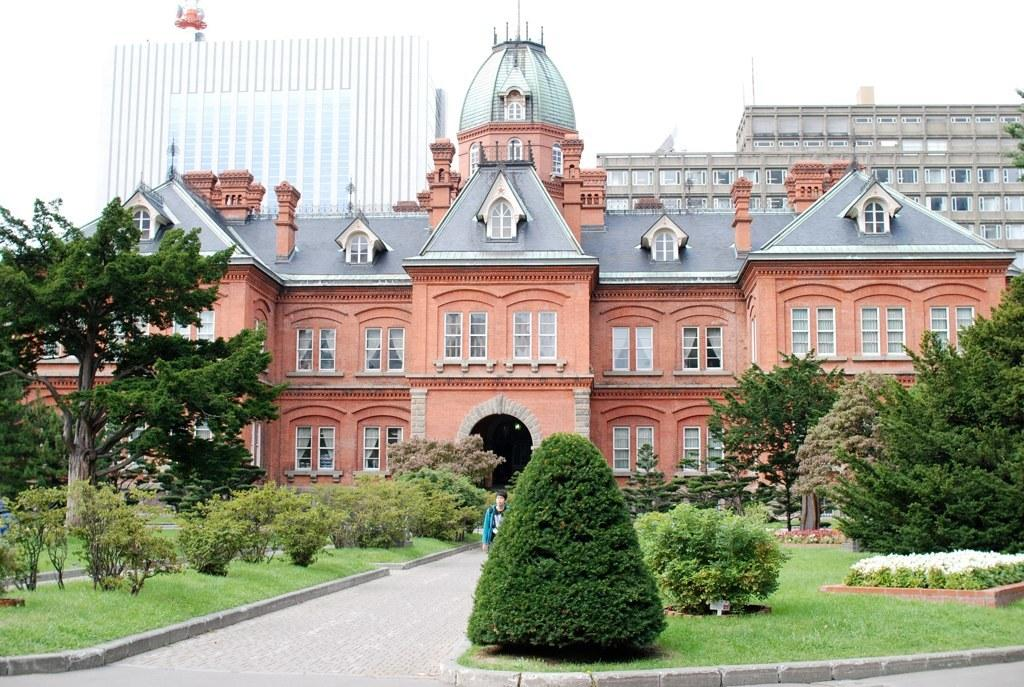Who is the main subject in the image? A: There is a man in the center of the image. Where is the man located in the image? The man is on the road. What can be seen in the background of the image? There are buildings, trees, and plants in the background of the image. What type of ornament is hanging from the trees in the image? There is no ornament hanging from the trees in the image; only trees and plants are present in the background. 